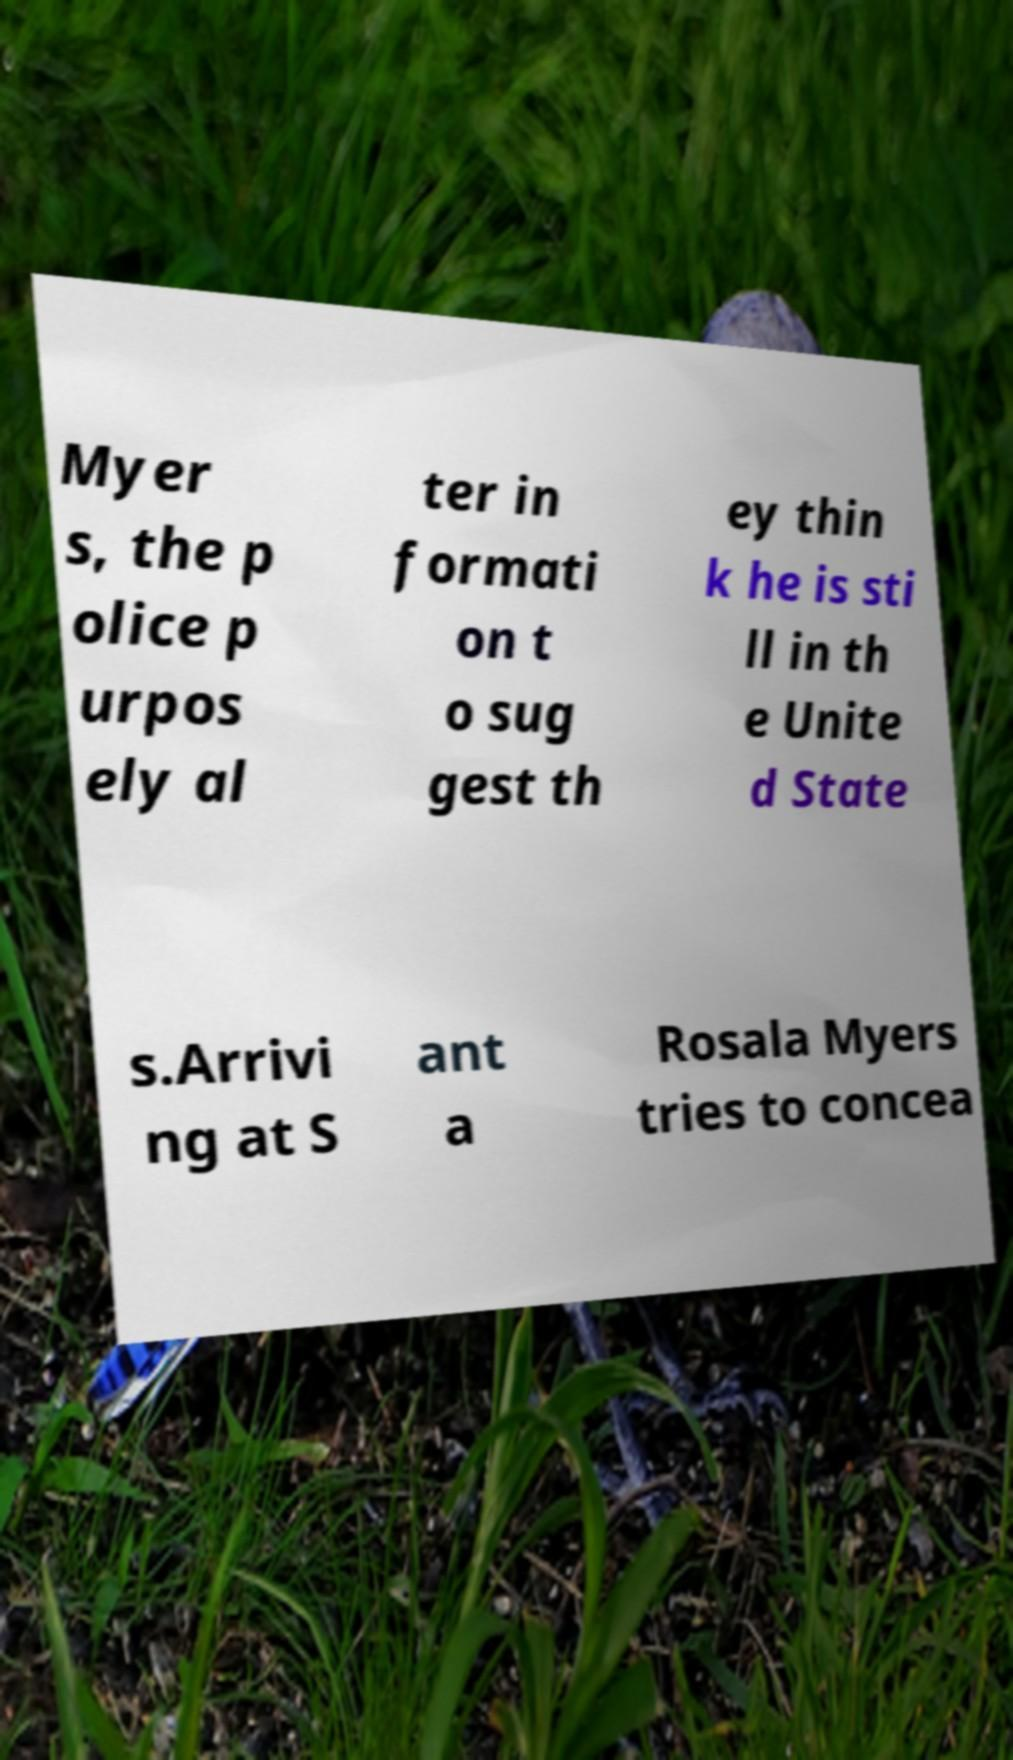Please read and relay the text visible in this image. What does it say? Myer s, the p olice p urpos ely al ter in formati on t o sug gest th ey thin k he is sti ll in th e Unite d State s.Arrivi ng at S ant a Rosala Myers tries to concea 